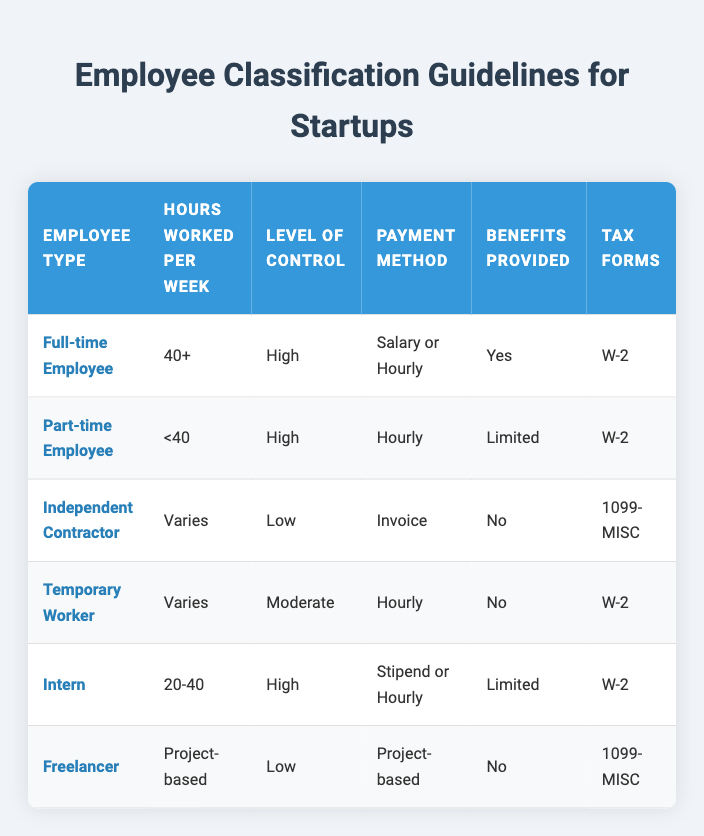What is the employee type for someone who works 40 hours or more per week? According to the table, a Full-time Employee is classified as working 40+ hours per week.
Answer: Full-time Employee How many employee types offer benefits? The table includes Full-time Employee and Intern as those that provide benefits. Therefore, there are 2 employee types that offer benefits.
Answer: 2 Do independent contractors receive any benefits? The table states that Independent Contractors do not receive benefits, so the answer is no.
Answer: No What tax form do part-time employees use? The table indicates that Part-time Employees use the W-2 tax form.
Answer: W-2 Which employee type has a moderate level of control? The table shows that Temporary Workers have a moderate level of control.
Answer: Temporary Worker What is the difference in the payment method between Independent Contractors and Freelancers? Independent Contractors use Invoice while Freelancers use Project-based as their payment method. Therefore, the difference is that one is paid via Invoice and the other via Project-based terms.
Answer: Invoice and Project-based Which employee types have a high level of control and are classified under specific hours worked per week? The Full-time Employee, Part-time Employee, and Intern all have a high level of control. Full-time Employee is associated with 40+ hours, Part-time Employee with <40 hours, and Intern with 20-40 hours. Hence, there are three employee types.
Answer: 3 If a worker is paid hourly and does not receive benefits, what employee type could they be? There are two possible classifications: Part-time Employee fits as they are paid hourly and receive limited benefits, while Temporary Worker does not receive any benefits and is also paid hourly. However, since the question specifies that the employee does not receive benefits, the implication is that they would be classified as a Temporary Worker.
Answer: Temporary Worker Do all employee types use the W-2 tax form? Upon reviewing the table, Independent Contractors and Freelancers utilize the 1099-MISC tax form, which means not all employee types use the W-2 form.
Answer: No 